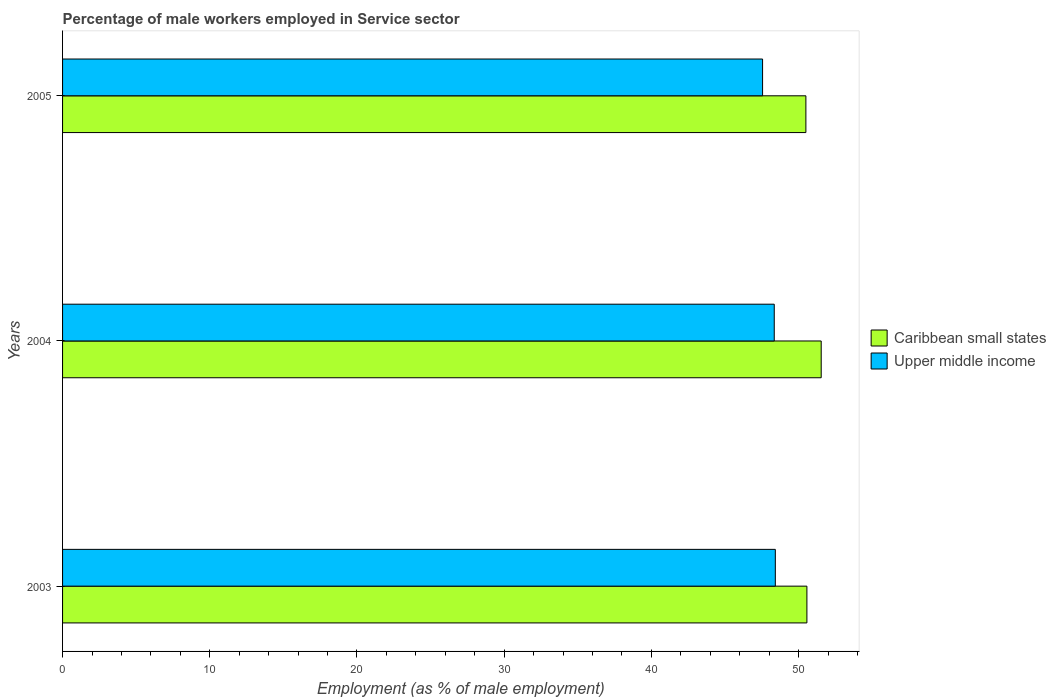How many groups of bars are there?
Ensure brevity in your answer.  3. Are the number of bars per tick equal to the number of legend labels?
Keep it short and to the point. Yes. Are the number of bars on each tick of the Y-axis equal?
Your response must be concise. Yes. What is the label of the 3rd group of bars from the top?
Your response must be concise. 2003. In how many cases, is the number of bars for a given year not equal to the number of legend labels?
Ensure brevity in your answer.  0. What is the percentage of male workers employed in Service sector in Caribbean small states in 2004?
Provide a succinct answer. 51.54. Across all years, what is the maximum percentage of male workers employed in Service sector in Caribbean small states?
Your answer should be very brief. 51.54. Across all years, what is the minimum percentage of male workers employed in Service sector in Upper middle income?
Ensure brevity in your answer.  47.55. What is the total percentage of male workers employed in Service sector in Upper middle income in the graph?
Make the answer very short. 144.32. What is the difference between the percentage of male workers employed in Service sector in Caribbean small states in 2003 and that in 2005?
Provide a short and direct response. 0.07. What is the difference between the percentage of male workers employed in Service sector in Upper middle income in 2005 and the percentage of male workers employed in Service sector in Caribbean small states in 2003?
Ensure brevity in your answer.  -3.01. What is the average percentage of male workers employed in Service sector in Upper middle income per year?
Your answer should be very brief. 48.11. In the year 2005, what is the difference between the percentage of male workers employed in Service sector in Caribbean small states and percentage of male workers employed in Service sector in Upper middle income?
Ensure brevity in your answer.  2.94. What is the ratio of the percentage of male workers employed in Service sector in Caribbean small states in 2003 to that in 2004?
Your response must be concise. 0.98. What is the difference between the highest and the second highest percentage of male workers employed in Service sector in Caribbean small states?
Make the answer very short. 0.97. What is the difference between the highest and the lowest percentage of male workers employed in Service sector in Upper middle income?
Provide a succinct answer. 0.87. In how many years, is the percentage of male workers employed in Service sector in Upper middle income greater than the average percentage of male workers employed in Service sector in Upper middle income taken over all years?
Keep it short and to the point. 2. What does the 1st bar from the top in 2004 represents?
Give a very brief answer. Upper middle income. What does the 2nd bar from the bottom in 2003 represents?
Keep it short and to the point. Upper middle income. How many bars are there?
Give a very brief answer. 6. How many years are there in the graph?
Offer a terse response. 3. What is the difference between two consecutive major ticks on the X-axis?
Provide a short and direct response. 10. Does the graph contain any zero values?
Ensure brevity in your answer.  No. Does the graph contain grids?
Your response must be concise. No. What is the title of the graph?
Your answer should be very brief. Percentage of male workers employed in Service sector. Does "Mexico" appear as one of the legend labels in the graph?
Offer a very short reply. No. What is the label or title of the X-axis?
Your answer should be compact. Employment (as % of male employment). What is the label or title of the Y-axis?
Keep it short and to the point. Years. What is the Employment (as % of male employment) in Caribbean small states in 2003?
Your answer should be compact. 50.57. What is the Employment (as % of male employment) of Upper middle income in 2003?
Your response must be concise. 48.42. What is the Employment (as % of male employment) of Caribbean small states in 2004?
Keep it short and to the point. 51.54. What is the Employment (as % of male employment) in Upper middle income in 2004?
Ensure brevity in your answer.  48.35. What is the Employment (as % of male employment) in Caribbean small states in 2005?
Offer a terse response. 50.5. What is the Employment (as % of male employment) of Upper middle income in 2005?
Make the answer very short. 47.55. Across all years, what is the maximum Employment (as % of male employment) in Caribbean small states?
Your response must be concise. 51.54. Across all years, what is the maximum Employment (as % of male employment) in Upper middle income?
Your answer should be compact. 48.42. Across all years, what is the minimum Employment (as % of male employment) in Caribbean small states?
Offer a very short reply. 50.5. Across all years, what is the minimum Employment (as % of male employment) of Upper middle income?
Your response must be concise. 47.55. What is the total Employment (as % of male employment) in Caribbean small states in the graph?
Make the answer very short. 152.6. What is the total Employment (as % of male employment) of Upper middle income in the graph?
Your answer should be compact. 144.32. What is the difference between the Employment (as % of male employment) of Caribbean small states in 2003 and that in 2004?
Make the answer very short. -0.97. What is the difference between the Employment (as % of male employment) in Upper middle income in 2003 and that in 2004?
Offer a terse response. 0.07. What is the difference between the Employment (as % of male employment) in Caribbean small states in 2003 and that in 2005?
Provide a short and direct response. 0.07. What is the difference between the Employment (as % of male employment) in Upper middle income in 2003 and that in 2005?
Make the answer very short. 0.87. What is the difference between the Employment (as % of male employment) in Caribbean small states in 2004 and that in 2005?
Make the answer very short. 1.04. What is the difference between the Employment (as % of male employment) of Upper middle income in 2004 and that in 2005?
Ensure brevity in your answer.  0.79. What is the difference between the Employment (as % of male employment) in Caribbean small states in 2003 and the Employment (as % of male employment) in Upper middle income in 2004?
Your answer should be compact. 2.22. What is the difference between the Employment (as % of male employment) in Caribbean small states in 2003 and the Employment (as % of male employment) in Upper middle income in 2005?
Offer a terse response. 3.01. What is the difference between the Employment (as % of male employment) of Caribbean small states in 2004 and the Employment (as % of male employment) of Upper middle income in 2005?
Offer a very short reply. 3.98. What is the average Employment (as % of male employment) in Caribbean small states per year?
Offer a terse response. 50.87. What is the average Employment (as % of male employment) in Upper middle income per year?
Your answer should be compact. 48.11. In the year 2003, what is the difference between the Employment (as % of male employment) in Caribbean small states and Employment (as % of male employment) in Upper middle income?
Keep it short and to the point. 2.15. In the year 2004, what is the difference between the Employment (as % of male employment) in Caribbean small states and Employment (as % of male employment) in Upper middle income?
Offer a very short reply. 3.19. In the year 2005, what is the difference between the Employment (as % of male employment) in Caribbean small states and Employment (as % of male employment) in Upper middle income?
Keep it short and to the point. 2.94. What is the ratio of the Employment (as % of male employment) of Caribbean small states in 2003 to that in 2004?
Your answer should be very brief. 0.98. What is the ratio of the Employment (as % of male employment) of Upper middle income in 2003 to that in 2004?
Your answer should be compact. 1. What is the ratio of the Employment (as % of male employment) in Caribbean small states in 2003 to that in 2005?
Make the answer very short. 1. What is the ratio of the Employment (as % of male employment) in Upper middle income in 2003 to that in 2005?
Provide a short and direct response. 1.02. What is the ratio of the Employment (as % of male employment) in Caribbean small states in 2004 to that in 2005?
Offer a terse response. 1.02. What is the ratio of the Employment (as % of male employment) in Upper middle income in 2004 to that in 2005?
Provide a succinct answer. 1.02. What is the difference between the highest and the second highest Employment (as % of male employment) in Caribbean small states?
Your response must be concise. 0.97. What is the difference between the highest and the second highest Employment (as % of male employment) of Upper middle income?
Provide a succinct answer. 0.07. What is the difference between the highest and the lowest Employment (as % of male employment) of Caribbean small states?
Give a very brief answer. 1.04. What is the difference between the highest and the lowest Employment (as % of male employment) of Upper middle income?
Provide a succinct answer. 0.87. 